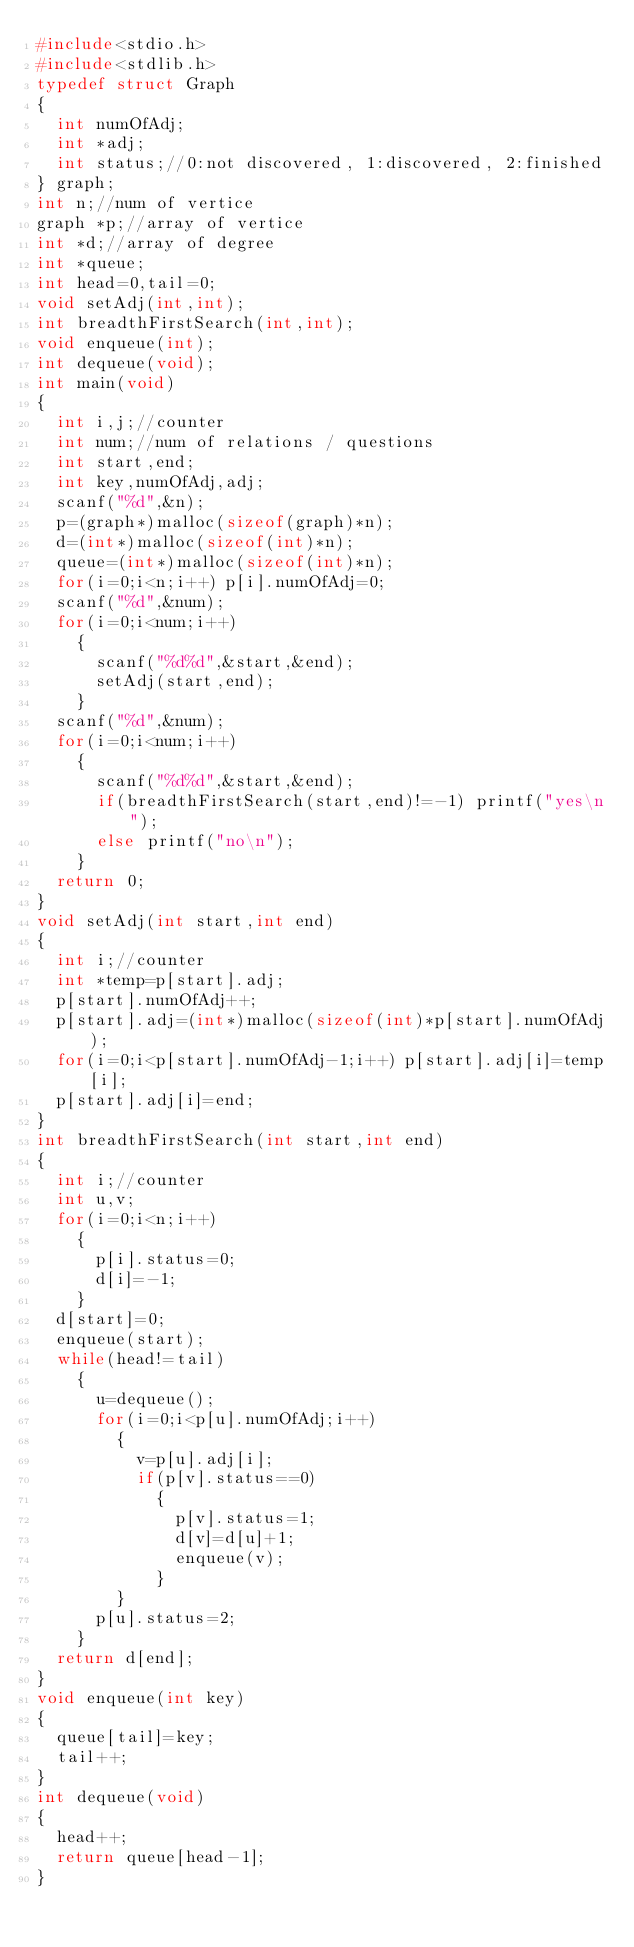<code> <loc_0><loc_0><loc_500><loc_500><_C_>#include<stdio.h>
#include<stdlib.h>
typedef struct Graph
{
  int numOfAdj;
  int *adj;
  int status;//0:not discovered, 1:discovered, 2:finished
} graph;
int n;//num of vertice
graph *p;//array of vertice
int *d;//array of degree
int *queue;
int head=0,tail=0;
void setAdj(int,int);
int breadthFirstSearch(int,int);
void enqueue(int);
int dequeue(void);
int main(void)
{
  int i,j;//counter
  int num;//num of relations / questions
  int start,end;
  int key,numOfAdj,adj;
  scanf("%d",&n);
  p=(graph*)malloc(sizeof(graph)*n);
  d=(int*)malloc(sizeof(int)*n);
  queue=(int*)malloc(sizeof(int)*n);
  for(i=0;i<n;i++) p[i].numOfAdj=0;
  scanf("%d",&num);
  for(i=0;i<num;i++)
    {
      scanf("%d%d",&start,&end);
      setAdj(start,end);
    }
  scanf("%d",&num);
  for(i=0;i<num;i++)
    {
      scanf("%d%d",&start,&end);
      if(breadthFirstSearch(start,end)!=-1) printf("yes\n");
      else printf("no\n");
    }
  return 0;
}
void setAdj(int start,int end)
{
  int i;//counter
  int *temp=p[start].adj;
  p[start].numOfAdj++;
  p[start].adj=(int*)malloc(sizeof(int)*p[start].numOfAdj);
  for(i=0;i<p[start].numOfAdj-1;i++) p[start].adj[i]=temp[i];
  p[start].adj[i]=end;
}
int breadthFirstSearch(int start,int end)
{
  int i;//counter
  int u,v;
  for(i=0;i<n;i++)
    {
      p[i].status=0;
      d[i]=-1;
    }
  d[start]=0;
  enqueue(start);
  while(head!=tail)
    {
      u=dequeue();
      for(i=0;i<p[u].numOfAdj;i++)
        {
          v=p[u].adj[i];
          if(p[v].status==0)
            {
              p[v].status=1;
              d[v]=d[u]+1;
              enqueue(v);
            }
        }
      p[u].status=2;
    }
  return d[end];
}
void enqueue(int key)
{
  queue[tail]=key;
  tail++;
}
int dequeue(void)
{
  head++;
  return queue[head-1];
}
</code> 